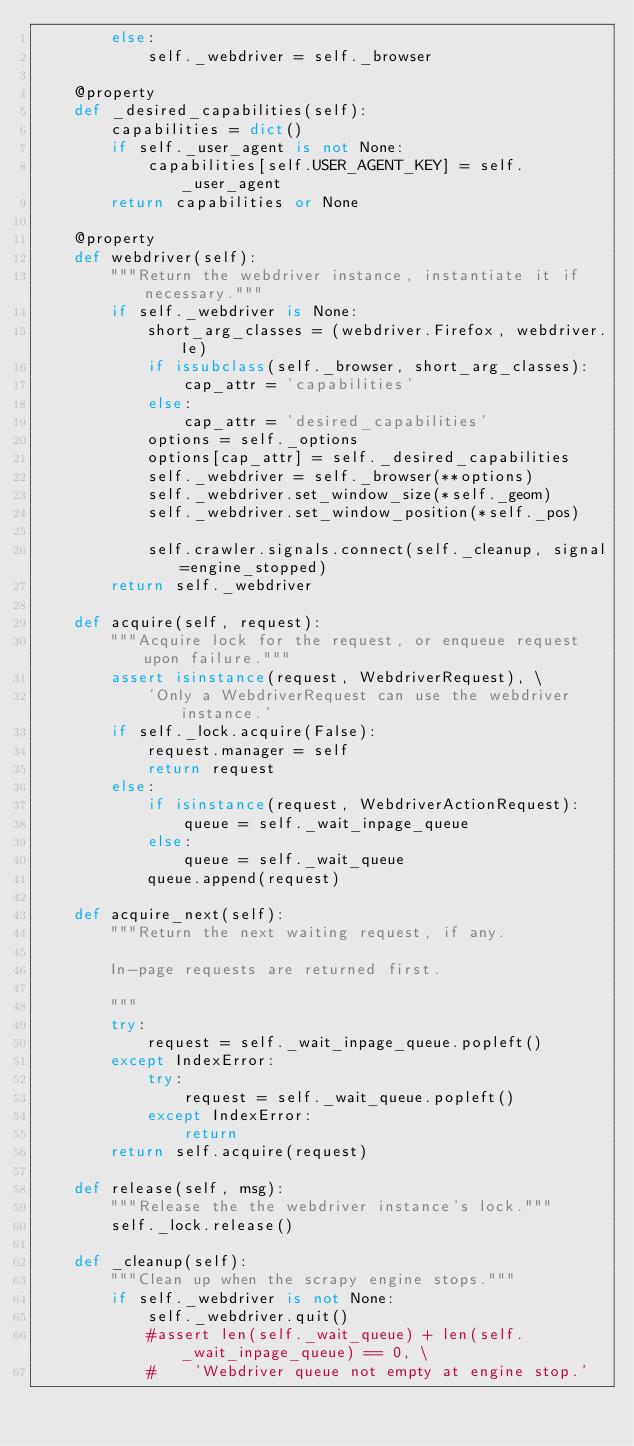Convert code to text. <code><loc_0><loc_0><loc_500><loc_500><_Python_>        else:
            self._webdriver = self._browser

    @property
    def _desired_capabilities(self):
        capabilities = dict()
        if self._user_agent is not None:
            capabilities[self.USER_AGENT_KEY] = self._user_agent
        return capabilities or None

    @property
    def webdriver(self):
        """Return the webdriver instance, instantiate it if necessary."""
        if self._webdriver is None:
            short_arg_classes = (webdriver.Firefox, webdriver.Ie)
            if issubclass(self._browser, short_arg_classes):
                cap_attr = 'capabilities'
            else:
                cap_attr = 'desired_capabilities'
            options = self._options
            options[cap_attr] = self._desired_capabilities
            self._webdriver = self._browser(**options)
            self._webdriver.set_window_size(*self._geom)
            self._webdriver.set_window_position(*self._pos)
        
            self.crawler.signals.connect(self._cleanup, signal=engine_stopped)
        return self._webdriver

    def acquire(self, request):
        """Acquire lock for the request, or enqueue request upon failure."""
        assert isinstance(request, WebdriverRequest), \
            'Only a WebdriverRequest can use the webdriver instance.'
        if self._lock.acquire(False):
            request.manager = self
            return request
        else:
            if isinstance(request, WebdriverActionRequest):
                queue = self._wait_inpage_queue
            else:
                queue = self._wait_queue
            queue.append(request)

    def acquire_next(self):
        """Return the next waiting request, if any.

        In-page requests are returned first.

        """
        try:
            request = self._wait_inpage_queue.popleft()
        except IndexError:
            try:
                request = self._wait_queue.popleft()
            except IndexError:
                return
        return self.acquire(request)

    def release(self, msg):
        """Release the the webdriver instance's lock."""
        self._lock.release()

    def _cleanup(self):
        """Clean up when the scrapy engine stops."""
        if self._webdriver is not None:
            self._webdriver.quit()
            #assert len(self._wait_queue) + len(self._wait_inpage_queue) == 0, \
            #    'Webdriver queue not empty at engine stop.'
</code> 